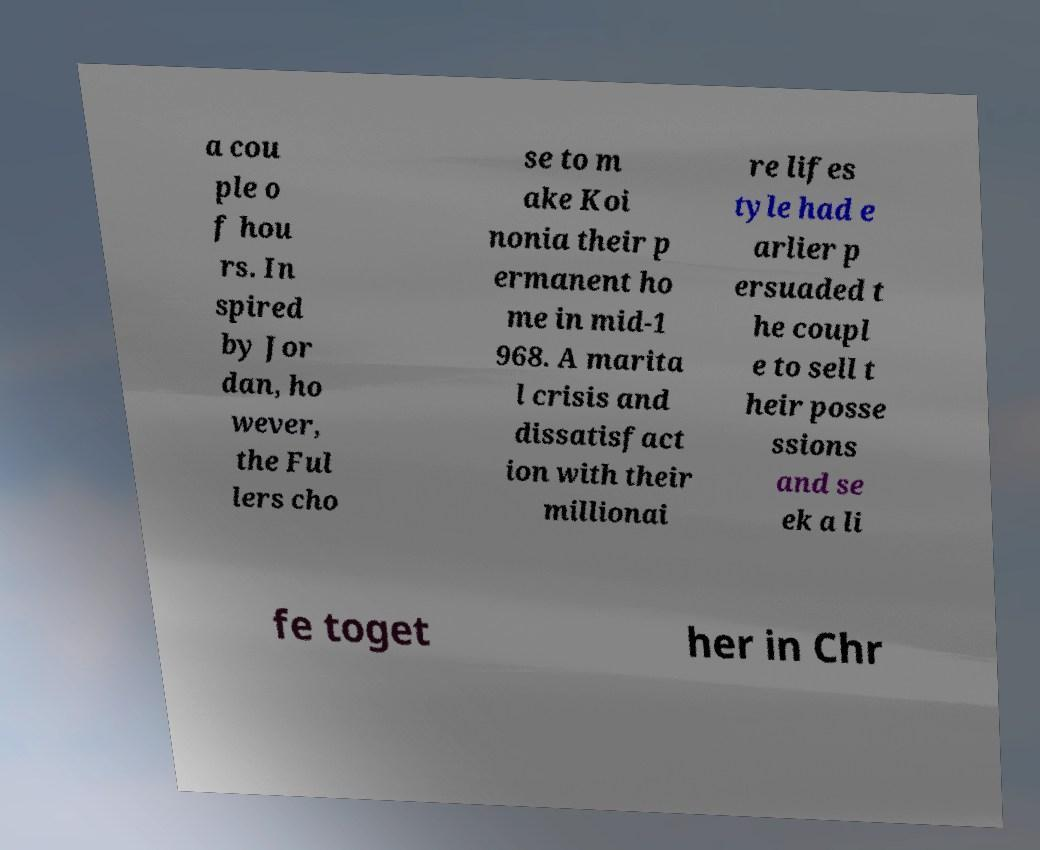Can you read and provide the text displayed in the image?This photo seems to have some interesting text. Can you extract and type it out for me? a cou ple o f hou rs. In spired by Jor dan, ho wever, the Ful lers cho se to m ake Koi nonia their p ermanent ho me in mid-1 968. A marita l crisis and dissatisfact ion with their millionai re lifes tyle had e arlier p ersuaded t he coupl e to sell t heir posse ssions and se ek a li fe toget her in Chr 